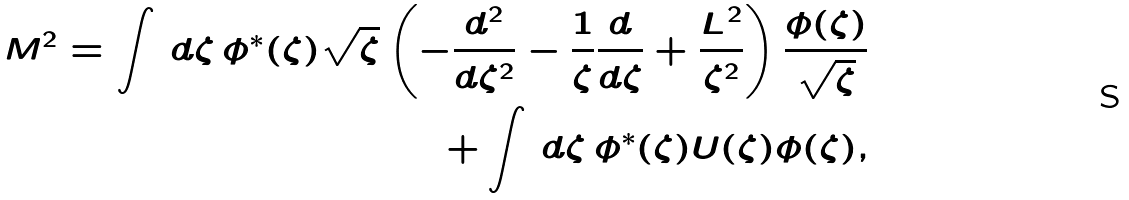Convert formula to latex. <formula><loc_0><loc_0><loc_500><loc_500>M ^ { 2 } = \int \, d \zeta \, \phi ^ { * } ( \zeta ) \sqrt { \zeta } \left ( - \frac { d ^ { 2 } } { d \zeta ^ { 2 } } - \frac { 1 } { \zeta } \frac { d } { d \zeta } + \frac { L ^ { 2 } } { \zeta ^ { 2 } } \right ) \frac { \phi ( \zeta ) } { \sqrt { \zeta } } \\ + \int \, d \zeta \, \phi ^ { * } ( \zeta ) U ( \zeta ) \phi ( \zeta ) ,</formula> 